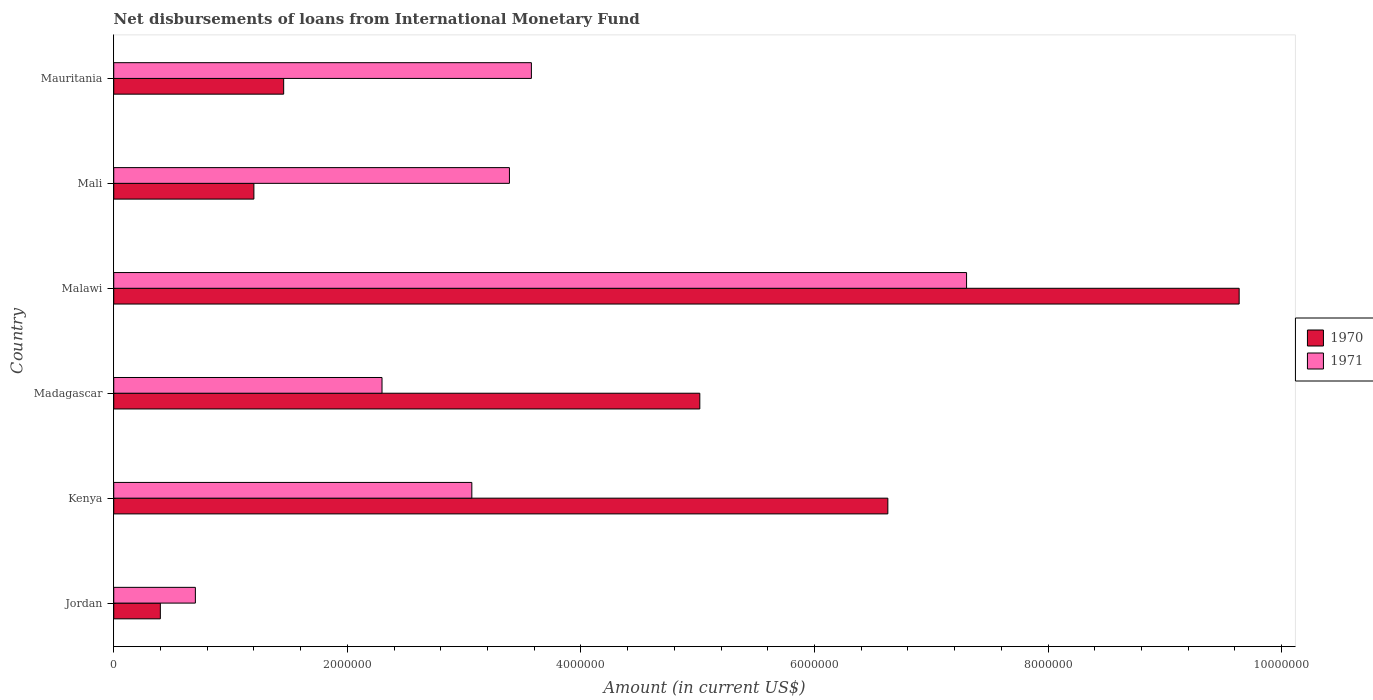How many different coloured bars are there?
Provide a short and direct response. 2. Are the number of bars per tick equal to the number of legend labels?
Give a very brief answer. Yes. Are the number of bars on each tick of the Y-axis equal?
Provide a short and direct response. Yes. How many bars are there on the 6th tick from the top?
Give a very brief answer. 2. How many bars are there on the 4th tick from the bottom?
Keep it short and to the point. 2. What is the label of the 3rd group of bars from the top?
Make the answer very short. Malawi. What is the amount of loans disbursed in 1971 in Kenya?
Provide a short and direct response. 3.07e+06. Across all countries, what is the maximum amount of loans disbursed in 1970?
Provide a succinct answer. 9.64e+06. Across all countries, what is the minimum amount of loans disbursed in 1970?
Make the answer very short. 3.99e+05. In which country was the amount of loans disbursed in 1971 maximum?
Make the answer very short. Malawi. In which country was the amount of loans disbursed in 1971 minimum?
Your answer should be compact. Jordan. What is the total amount of loans disbursed in 1970 in the graph?
Offer a terse response. 2.43e+07. What is the difference between the amount of loans disbursed in 1970 in Jordan and that in Malawi?
Your answer should be compact. -9.24e+06. What is the difference between the amount of loans disbursed in 1971 in Mali and the amount of loans disbursed in 1970 in Malawi?
Offer a terse response. -6.25e+06. What is the average amount of loans disbursed in 1971 per country?
Make the answer very short. 3.39e+06. What is the difference between the amount of loans disbursed in 1971 and amount of loans disbursed in 1970 in Malawi?
Your answer should be compact. -2.33e+06. In how many countries, is the amount of loans disbursed in 1971 greater than 7200000 US$?
Ensure brevity in your answer.  1. What is the ratio of the amount of loans disbursed in 1971 in Malawi to that in Mauritania?
Provide a succinct answer. 2.04. Is the amount of loans disbursed in 1971 in Jordan less than that in Madagascar?
Your answer should be compact. Yes. Is the difference between the amount of loans disbursed in 1971 in Kenya and Mauritania greater than the difference between the amount of loans disbursed in 1970 in Kenya and Mauritania?
Provide a succinct answer. No. What is the difference between the highest and the second highest amount of loans disbursed in 1970?
Give a very brief answer. 3.01e+06. What is the difference between the highest and the lowest amount of loans disbursed in 1970?
Ensure brevity in your answer.  9.24e+06. What does the 1st bar from the bottom in Kenya represents?
Your response must be concise. 1970. How many bars are there?
Keep it short and to the point. 12. What is the difference between two consecutive major ticks on the X-axis?
Your response must be concise. 2.00e+06. Does the graph contain any zero values?
Your answer should be very brief. No. Does the graph contain grids?
Provide a succinct answer. No. Where does the legend appear in the graph?
Make the answer very short. Center right. How are the legend labels stacked?
Provide a short and direct response. Vertical. What is the title of the graph?
Offer a very short reply. Net disbursements of loans from International Monetary Fund. What is the label or title of the X-axis?
Make the answer very short. Amount (in current US$). What is the Amount (in current US$) in 1970 in Jordan?
Offer a very short reply. 3.99e+05. What is the Amount (in current US$) of 1971 in Jordan?
Offer a very short reply. 6.99e+05. What is the Amount (in current US$) in 1970 in Kenya?
Make the answer very short. 6.63e+06. What is the Amount (in current US$) of 1971 in Kenya?
Your answer should be very brief. 3.07e+06. What is the Amount (in current US$) of 1970 in Madagascar?
Ensure brevity in your answer.  5.02e+06. What is the Amount (in current US$) of 1971 in Madagascar?
Ensure brevity in your answer.  2.30e+06. What is the Amount (in current US$) in 1970 in Malawi?
Keep it short and to the point. 9.64e+06. What is the Amount (in current US$) in 1971 in Malawi?
Your answer should be compact. 7.30e+06. What is the Amount (in current US$) in 1970 in Mali?
Offer a terse response. 1.20e+06. What is the Amount (in current US$) of 1971 in Mali?
Keep it short and to the point. 3.39e+06. What is the Amount (in current US$) in 1970 in Mauritania?
Provide a short and direct response. 1.46e+06. What is the Amount (in current US$) in 1971 in Mauritania?
Make the answer very short. 3.58e+06. Across all countries, what is the maximum Amount (in current US$) of 1970?
Give a very brief answer. 9.64e+06. Across all countries, what is the maximum Amount (in current US$) in 1971?
Your response must be concise. 7.30e+06. Across all countries, what is the minimum Amount (in current US$) in 1970?
Give a very brief answer. 3.99e+05. Across all countries, what is the minimum Amount (in current US$) of 1971?
Provide a succinct answer. 6.99e+05. What is the total Amount (in current US$) of 1970 in the graph?
Give a very brief answer. 2.43e+07. What is the total Amount (in current US$) in 1971 in the graph?
Provide a short and direct response. 2.03e+07. What is the difference between the Amount (in current US$) in 1970 in Jordan and that in Kenya?
Offer a terse response. -6.23e+06. What is the difference between the Amount (in current US$) of 1971 in Jordan and that in Kenya?
Keep it short and to the point. -2.37e+06. What is the difference between the Amount (in current US$) in 1970 in Jordan and that in Madagascar?
Make the answer very short. -4.62e+06. What is the difference between the Amount (in current US$) of 1971 in Jordan and that in Madagascar?
Offer a very short reply. -1.60e+06. What is the difference between the Amount (in current US$) in 1970 in Jordan and that in Malawi?
Give a very brief answer. -9.24e+06. What is the difference between the Amount (in current US$) in 1971 in Jordan and that in Malawi?
Provide a succinct answer. -6.60e+06. What is the difference between the Amount (in current US$) in 1970 in Jordan and that in Mali?
Offer a terse response. -8.01e+05. What is the difference between the Amount (in current US$) in 1971 in Jordan and that in Mali?
Give a very brief answer. -2.69e+06. What is the difference between the Amount (in current US$) in 1970 in Jordan and that in Mauritania?
Your answer should be very brief. -1.06e+06. What is the difference between the Amount (in current US$) in 1971 in Jordan and that in Mauritania?
Your response must be concise. -2.88e+06. What is the difference between the Amount (in current US$) of 1970 in Kenya and that in Madagascar?
Keep it short and to the point. 1.61e+06. What is the difference between the Amount (in current US$) of 1971 in Kenya and that in Madagascar?
Make the answer very short. 7.69e+05. What is the difference between the Amount (in current US$) of 1970 in Kenya and that in Malawi?
Provide a short and direct response. -3.01e+06. What is the difference between the Amount (in current US$) of 1971 in Kenya and that in Malawi?
Your answer should be very brief. -4.24e+06. What is the difference between the Amount (in current US$) of 1970 in Kenya and that in Mali?
Your answer should be very brief. 5.43e+06. What is the difference between the Amount (in current US$) of 1971 in Kenya and that in Mali?
Your response must be concise. -3.22e+05. What is the difference between the Amount (in current US$) of 1970 in Kenya and that in Mauritania?
Give a very brief answer. 5.17e+06. What is the difference between the Amount (in current US$) of 1971 in Kenya and that in Mauritania?
Offer a very short reply. -5.10e+05. What is the difference between the Amount (in current US$) of 1970 in Madagascar and that in Malawi?
Make the answer very short. -4.62e+06. What is the difference between the Amount (in current US$) in 1971 in Madagascar and that in Malawi?
Provide a short and direct response. -5.00e+06. What is the difference between the Amount (in current US$) in 1970 in Madagascar and that in Mali?
Keep it short and to the point. 3.82e+06. What is the difference between the Amount (in current US$) in 1971 in Madagascar and that in Mali?
Your response must be concise. -1.09e+06. What is the difference between the Amount (in current US$) of 1970 in Madagascar and that in Mauritania?
Keep it short and to the point. 3.56e+06. What is the difference between the Amount (in current US$) in 1971 in Madagascar and that in Mauritania?
Your answer should be compact. -1.28e+06. What is the difference between the Amount (in current US$) of 1970 in Malawi and that in Mali?
Provide a short and direct response. 8.44e+06. What is the difference between the Amount (in current US$) of 1971 in Malawi and that in Mali?
Ensure brevity in your answer.  3.91e+06. What is the difference between the Amount (in current US$) of 1970 in Malawi and that in Mauritania?
Your answer should be very brief. 8.18e+06. What is the difference between the Amount (in current US$) in 1971 in Malawi and that in Mauritania?
Provide a succinct answer. 3.73e+06. What is the difference between the Amount (in current US$) of 1970 in Mali and that in Mauritania?
Keep it short and to the point. -2.55e+05. What is the difference between the Amount (in current US$) of 1971 in Mali and that in Mauritania?
Offer a very short reply. -1.88e+05. What is the difference between the Amount (in current US$) in 1970 in Jordan and the Amount (in current US$) in 1971 in Kenya?
Offer a very short reply. -2.67e+06. What is the difference between the Amount (in current US$) of 1970 in Jordan and the Amount (in current US$) of 1971 in Madagascar?
Your response must be concise. -1.90e+06. What is the difference between the Amount (in current US$) of 1970 in Jordan and the Amount (in current US$) of 1971 in Malawi?
Your answer should be compact. -6.90e+06. What is the difference between the Amount (in current US$) of 1970 in Jordan and the Amount (in current US$) of 1971 in Mali?
Your response must be concise. -2.99e+06. What is the difference between the Amount (in current US$) in 1970 in Jordan and the Amount (in current US$) in 1971 in Mauritania?
Your answer should be compact. -3.18e+06. What is the difference between the Amount (in current US$) of 1970 in Kenya and the Amount (in current US$) of 1971 in Madagascar?
Offer a very short reply. 4.33e+06. What is the difference between the Amount (in current US$) in 1970 in Kenya and the Amount (in current US$) in 1971 in Malawi?
Offer a very short reply. -6.74e+05. What is the difference between the Amount (in current US$) in 1970 in Kenya and the Amount (in current US$) in 1971 in Mali?
Keep it short and to the point. 3.24e+06. What is the difference between the Amount (in current US$) in 1970 in Kenya and the Amount (in current US$) in 1971 in Mauritania?
Make the answer very short. 3.05e+06. What is the difference between the Amount (in current US$) in 1970 in Madagascar and the Amount (in current US$) in 1971 in Malawi?
Your answer should be very brief. -2.28e+06. What is the difference between the Amount (in current US$) in 1970 in Madagascar and the Amount (in current US$) in 1971 in Mali?
Provide a short and direct response. 1.63e+06. What is the difference between the Amount (in current US$) in 1970 in Madagascar and the Amount (in current US$) in 1971 in Mauritania?
Give a very brief answer. 1.44e+06. What is the difference between the Amount (in current US$) in 1970 in Malawi and the Amount (in current US$) in 1971 in Mali?
Ensure brevity in your answer.  6.25e+06. What is the difference between the Amount (in current US$) of 1970 in Malawi and the Amount (in current US$) of 1971 in Mauritania?
Ensure brevity in your answer.  6.06e+06. What is the difference between the Amount (in current US$) in 1970 in Mali and the Amount (in current US$) in 1971 in Mauritania?
Offer a terse response. -2.38e+06. What is the average Amount (in current US$) of 1970 per country?
Give a very brief answer. 4.06e+06. What is the average Amount (in current US$) in 1971 per country?
Offer a very short reply. 3.39e+06. What is the difference between the Amount (in current US$) of 1970 and Amount (in current US$) of 1971 in Kenya?
Offer a terse response. 3.56e+06. What is the difference between the Amount (in current US$) in 1970 and Amount (in current US$) in 1971 in Madagascar?
Provide a short and direct response. 2.72e+06. What is the difference between the Amount (in current US$) of 1970 and Amount (in current US$) of 1971 in Malawi?
Keep it short and to the point. 2.33e+06. What is the difference between the Amount (in current US$) in 1970 and Amount (in current US$) in 1971 in Mali?
Make the answer very short. -2.19e+06. What is the difference between the Amount (in current US$) of 1970 and Amount (in current US$) of 1971 in Mauritania?
Provide a succinct answer. -2.12e+06. What is the ratio of the Amount (in current US$) in 1970 in Jordan to that in Kenya?
Make the answer very short. 0.06. What is the ratio of the Amount (in current US$) in 1971 in Jordan to that in Kenya?
Your response must be concise. 0.23. What is the ratio of the Amount (in current US$) in 1970 in Jordan to that in Madagascar?
Give a very brief answer. 0.08. What is the ratio of the Amount (in current US$) in 1971 in Jordan to that in Madagascar?
Offer a terse response. 0.3. What is the ratio of the Amount (in current US$) in 1970 in Jordan to that in Malawi?
Offer a very short reply. 0.04. What is the ratio of the Amount (in current US$) in 1971 in Jordan to that in Malawi?
Offer a very short reply. 0.1. What is the ratio of the Amount (in current US$) in 1970 in Jordan to that in Mali?
Provide a succinct answer. 0.33. What is the ratio of the Amount (in current US$) of 1971 in Jordan to that in Mali?
Provide a succinct answer. 0.21. What is the ratio of the Amount (in current US$) of 1970 in Jordan to that in Mauritania?
Ensure brevity in your answer.  0.27. What is the ratio of the Amount (in current US$) of 1971 in Jordan to that in Mauritania?
Your answer should be compact. 0.2. What is the ratio of the Amount (in current US$) in 1970 in Kenya to that in Madagascar?
Offer a very short reply. 1.32. What is the ratio of the Amount (in current US$) in 1971 in Kenya to that in Madagascar?
Make the answer very short. 1.33. What is the ratio of the Amount (in current US$) in 1970 in Kenya to that in Malawi?
Give a very brief answer. 0.69. What is the ratio of the Amount (in current US$) of 1971 in Kenya to that in Malawi?
Offer a very short reply. 0.42. What is the ratio of the Amount (in current US$) in 1970 in Kenya to that in Mali?
Your answer should be compact. 5.52. What is the ratio of the Amount (in current US$) in 1971 in Kenya to that in Mali?
Provide a succinct answer. 0.91. What is the ratio of the Amount (in current US$) in 1970 in Kenya to that in Mauritania?
Your response must be concise. 4.56. What is the ratio of the Amount (in current US$) of 1971 in Kenya to that in Mauritania?
Provide a short and direct response. 0.86. What is the ratio of the Amount (in current US$) of 1970 in Madagascar to that in Malawi?
Provide a short and direct response. 0.52. What is the ratio of the Amount (in current US$) of 1971 in Madagascar to that in Malawi?
Keep it short and to the point. 0.31. What is the ratio of the Amount (in current US$) of 1970 in Madagascar to that in Mali?
Offer a terse response. 4.18. What is the ratio of the Amount (in current US$) in 1971 in Madagascar to that in Mali?
Your answer should be compact. 0.68. What is the ratio of the Amount (in current US$) of 1970 in Madagascar to that in Mauritania?
Provide a succinct answer. 3.45. What is the ratio of the Amount (in current US$) of 1971 in Madagascar to that in Mauritania?
Your answer should be compact. 0.64. What is the ratio of the Amount (in current US$) in 1970 in Malawi to that in Mali?
Offer a very short reply. 8.03. What is the ratio of the Amount (in current US$) of 1971 in Malawi to that in Mali?
Ensure brevity in your answer.  2.16. What is the ratio of the Amount (in current US$) in 1970 in Malawi to that in Mauritania?
Your response must be concise. 6.62. What is the ratio of the Amount (in current US$) in 1971 in Malawi to that in Mauritania?
Offer a very short reply. 2.04. What is the ratio of the Amount (in current US$) of 1970 in Mali to that in Mauritania?
Your response must be concise. 0.82. What is the ratio of the Amount (in current US$) of 1971 in Mali to that in Mauritania?
Your answer should be compact. 0.95. What is the difference between the highest and the second highest Amount (in current US$) in 1970?
Offer a terse response. 3.01e+06. What is the difference between the highest and the second highest Amount (in current US$) in 1971?
Your answer should be very brief. 3.73e+06. What is the difference between the highest and the lowest Amount (in current US$) of 1970?
Offer a very short reply. 9.24e+06. What is the difference between the highest and the lowest Amount (in current US$) of 1971?
Provide a short and direct response. 6.60e+06. 